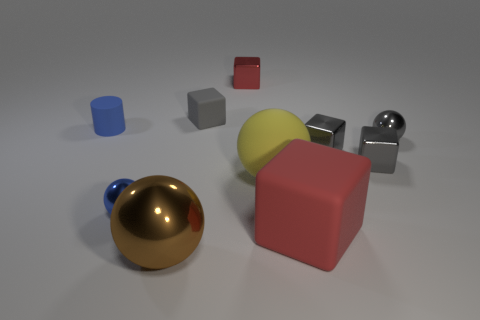Do the gray sphere and the sphere that is to the left of the brown object have the same material? Yes, the gray sphere and the sphere to the left of the brown cube appear to have the same reflective and smooth material characteristics, indicating that they are likely made of the same or very similar substances, such as polished metal or a metal-like composite. 